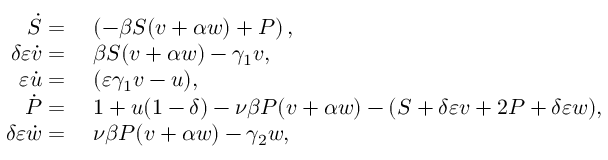Convert formula to latex. <formula><loc_0><loc_0><loc_500><loc_500>\begin{array} { r l } { \ D o t { S } = } & { \, \left ( - \beta S ( v + \alpha w ) + P \right ) , } \\ { \delta \varepsilon \ D o t { v } = } & { \, \beta S ( v + \alpha w ) - \gamma _ { 1 } v , } \\ { \varepsilon \ D o t { u } = } & { \, ( \varepsilon \gamma _ { 1 } v - u ) , } \\ { \ D o t { P } = } & { \, 1 + u ( 1 - \delta ) - \nu \beta P ( v + \alpha w ) - ( S + \delta \varepsilon v + 2 P + \delta \varepsilon w ) , } \\ { \delta \varepsilon \ D o t { w } = } & { \, \nu \beta P ( v + \alpha w ) - \gamma _ { 2 } w , } \end{array}</formula> 